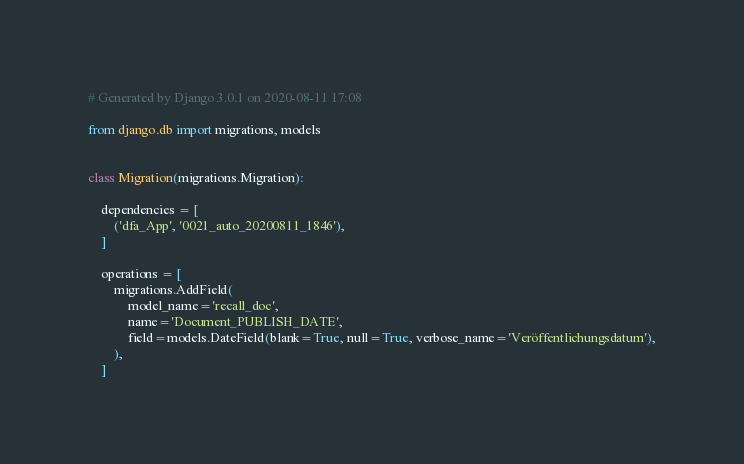Convert code to text. <code><loc_0><loc_0><loc_500><loc_500><_Python_># Generated by Django 3.0.1 on 2020-08-11 17:08

from django.db import migrations, models


class Migration(migrations.Migration):

    dependencies = [
        ('dfa_App', '0021_auto_20200811_1846'),
    ]

    operations = [
        migrations.AddField(
            model_name='recall_doc',
            name='Document_PUBLISH_DATE',
            field=models.DateField(blank=True, null=True, verbose_name='Veröffentlichungsdatum'),
        ),
    ]
</code> 